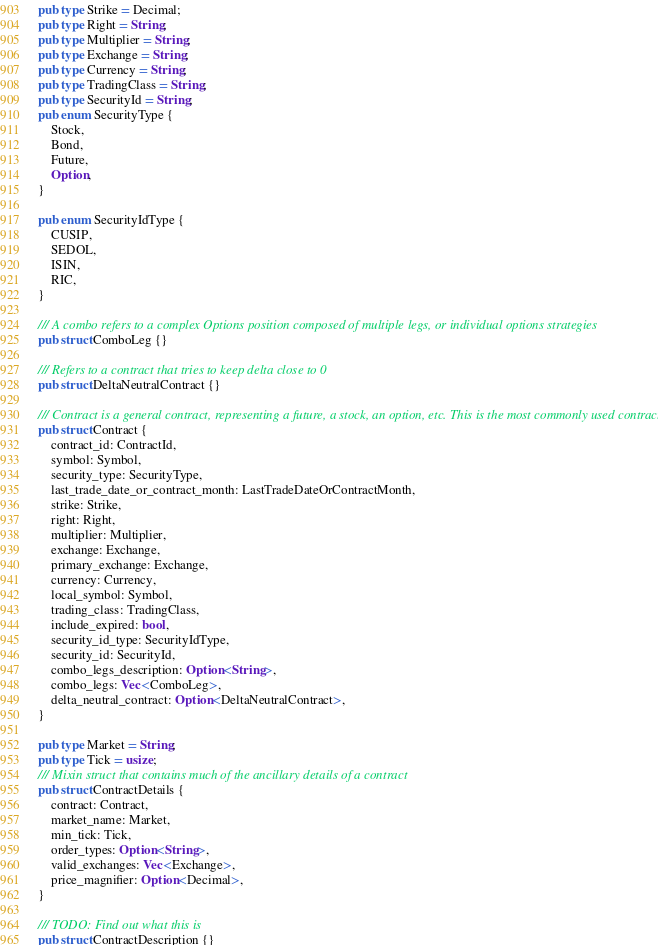<code> <loc_0><loc_0><loc_500><loc_500><_Rust_>pub type Strike = Decimal;
pub type Right = String;
pub type Multiplier = String;
pub type Exchange = String;
pub type Currency = String;
pub type TradingClass = String;
pub type SecurityId = String;
pub enum SecurityType {
    Stock,
    Bond,
    Future,
    Option,
}

pub enum SecurityIdType {
    CUSIP,
    SEDOL,
    ISIN,
    RIC,
}

/// A combo refers to a complex Options position composed of multiple legs, or individual options strategies
pub struct ComboLeg {}

/// Refers to a contract that tries to keep delta close to 0
pub struct DeltaNeutralContract {}

/// Contract is a general contract, representing a future, a stock, an option, etc. This is the most commonly used contract
pub struct Contract {
    contract_id: ContractId,
    symbol: Symbol,
    security_type: SecurityType,
    last_trade_date_or_contract_month: LastTradeDateOrContractMonth,
    strike: Strike,
    right: Right,
    multiplier: Multiplier,
    exchange: Exchange,
    primary_exchange: Exchange,
    currency: Currency,
    local_symbol: Symbol,
    trading_class: TradingClass,
    include_expired: bool,
    security_id_type: SecurityIdType,
    security_id: SecurityId,
    combo_legs_description: Option<String>,
    combo_legs: Vec<ComboLeg>,
    delta_neutral_contract: Option<DeltaNeutralContract>,
}

pub type Market = String;
pub type Tick = usize;
/// Mixin struct that contains much of the ancillary details of a contract
pub struct ContractDetails {
    contract: Contract,
    market_name: Market,
    min_tick: Tick,
    order_types: Option<String>,
    valid_exchanges: Vec<Exchange>,
    price_magnifier: Option<Decimal>,
}

/// TODO: Find out what this is
pub struct ContractDescription {}
</code> 